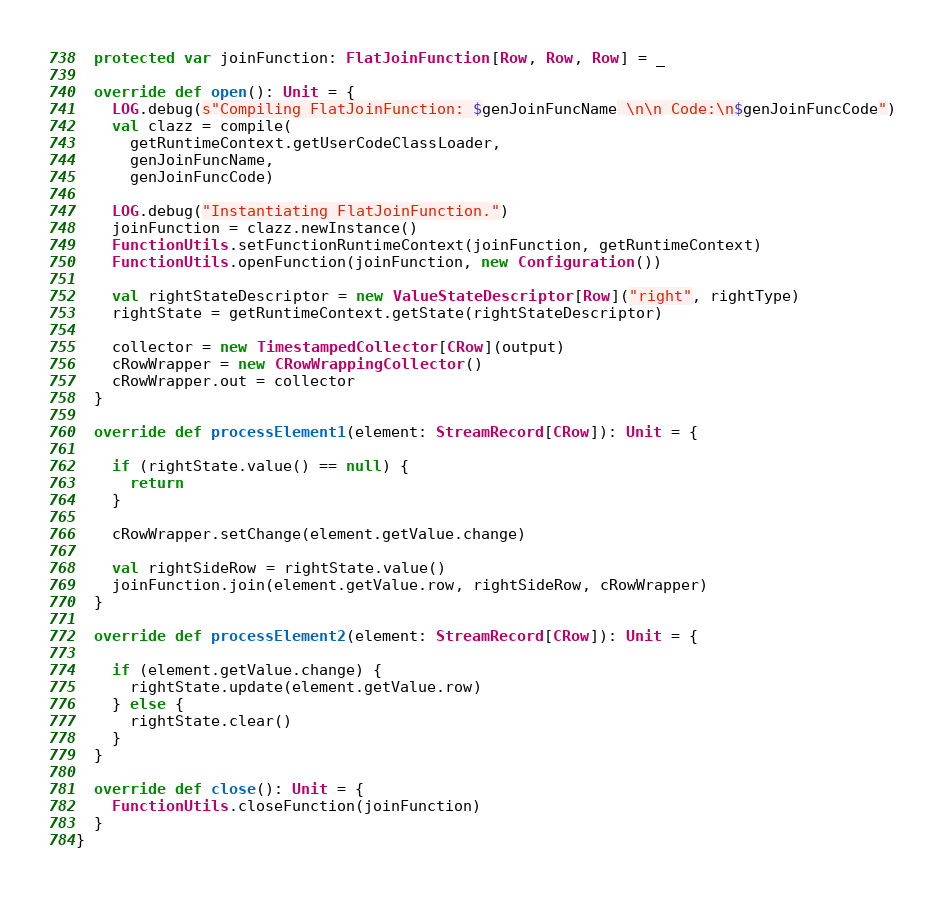<code> <loc_0><loc_0><loc_500><loc_500><_Scala_>  protected var joinFunction: FlatJoinFunction[Row, Row, Row] = _

  override def open(): Unit = {
    LOG.debug(s"Compiling FlatJoinFunction: $genJoinFuncName \n\n Code:\n$genJoinFuncCode")
    val clazz = compile(
      getRuntimeContext.getUserCodeClassLoader,
      genJoinFuncName,
      genJoinFuncCode)

    LOG.debug("Instantiating FlatJoinFunction.")
    joinFunction = clazz.newInstance()
    FunctionUtils.setFunctionRuntimeContext(joinFunction, getRuntimeContext)
    FunctionUtils.openFunction(joinFunction, new Configuration())

    val rightStateDescriptor = new ValueStateDescriptor[Row]("right", rightType)
    rightState = getRuntimeContext.getState(rightStateDescriptor)

    collector = new TimestampedCollector[CRow](output)
    cRowWrapper = new CRowWrappingCollector()
    cRowWrapper.out = collector
  }

  override def processElement1(element: StreamRecord[CRow]): Unit = {

    if (rightState.value() == null) {
      return
    }

    cRowWrapper.setChange(element.getValue.change)

    val rightSideRow = rightState.value()
    joinFunction.join(element.getValue.row, rightSideRow, cRowWrapper)
  }

  override def processElement2(element: StreamRecord[CRow]): Unit = {

    if (element.getValue.change) {
      rightState.update(element.getValue.row)
    } else {
      rightState.clear()
    }
  }

  override def close(): Unit = {
    FunctionUtils.closeFunction(joinFunction)
  }
}
</code> 